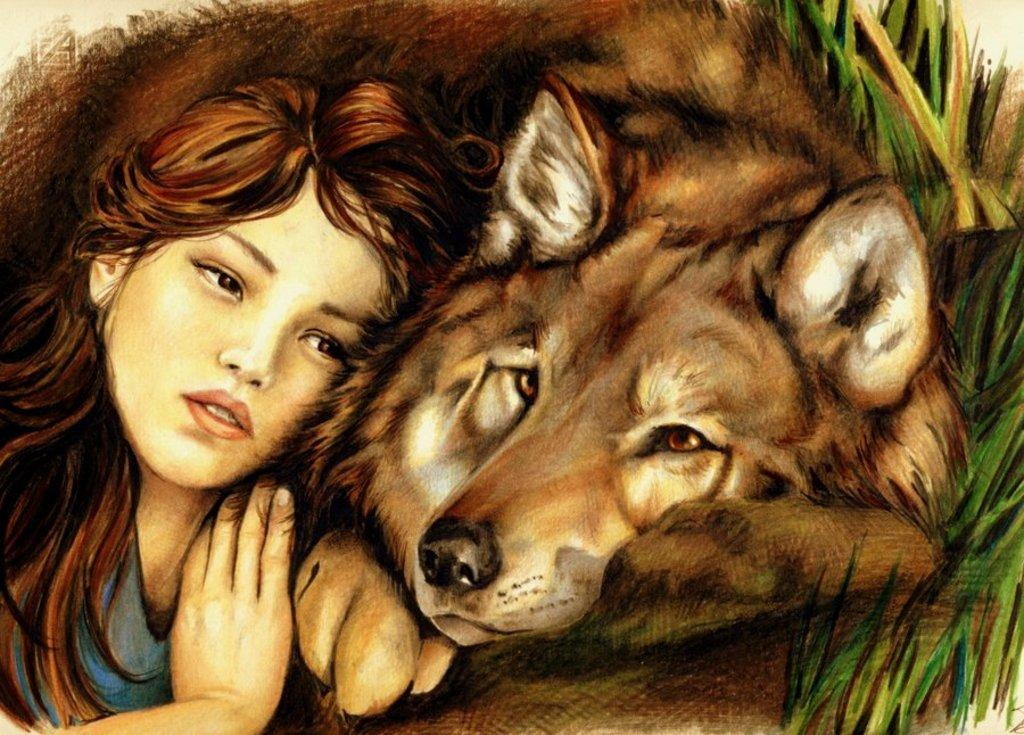What is depicted in the painting in the image? There is a painting of a girl in the image. What else can be seen in the image besides the painting? There is an animal lying in the image. What type of surface is the animal lying on? There is grass on the right side of the animal. How many women are present in the image? There is only one woman depicted in the image, and that is the girl in the painting. What does the grandfather in the image desire? There is no grandfather present in the image, so it is not possible to determine what he might desire. 